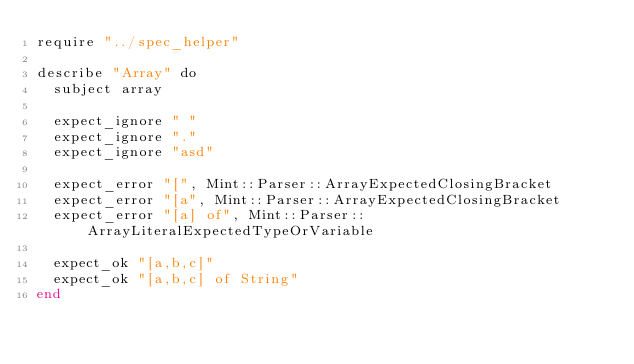Convert code to text. <code><loc_0><loc_0><loc_500><loc_500><_Crystal_>require "../spec_helper"

describe "Array" do
  subject array

  expect_ignore " "
  expect_ignore "."
  expect_ignore "asd"

  expect_error "[", Mint::Parser::ArrayExpectedClosingBracket
  expect_error "[a", Mint::Parser::ArrayExpectedClosingBracket
  expect_error "[a] of", Mint::Parser::ArrayLiteralExpectedTypeOrVariable

  expect_ok "[a,b,c]"
  expect_ok "[a,b,c] of String"
end
</code> 